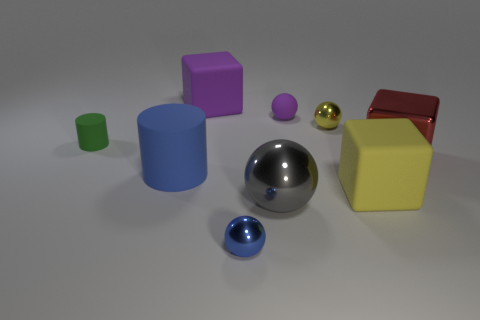Subtract all matte blocks. How many blocks are left? 1 Add 1 large cyan balls. How many objects exist? 10 Subtract all red cubes. How many cubes are left? 2 Subtract all spheres. How many objects are left? 5 Subtract all green cubes. Subtract all red balls. How many cubes are left? 3 Subtract all tiny gray metal cylinders. Subtract all gray spheres. How many objects are left? 8 Add 2 blue objects. How many blue objects are left? 4 Add 6 red shiny cylinders. How many red shiny cylinders exist? 6 Subtract 0 cyan blocks. How many objects are left? 9 